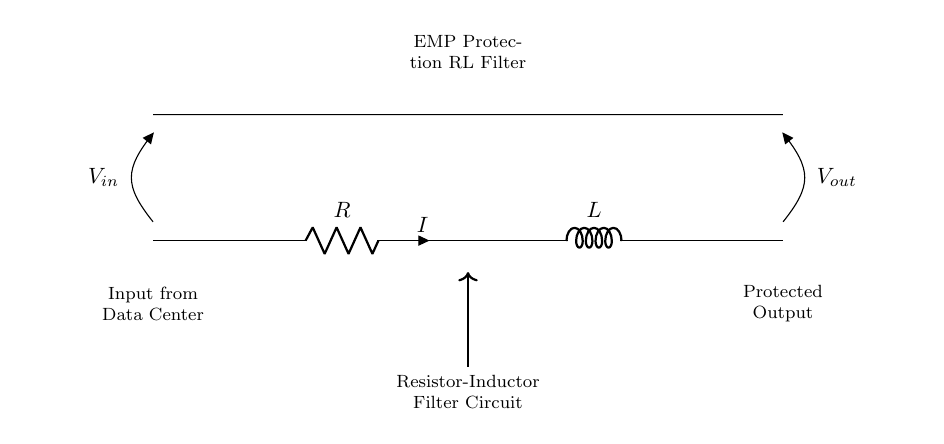What is the component labeled "R"? The component labeled "R" is a resistor, which is used to limit current in the circuit.
Answer: Resistor What is the component labeled "L"? The component labeled "L" is an inductor, which stores energy in the magnetic field and is used to filter frequencies.
Answer: Inductor What is the role of the resistor in this circuit? The resistor limits the current flow, helping to reduce the impact of electromagnetic interference from an EMP event.
Answer: Current limiter What does "V_in" represent? "V_in" represents the input voltage supplied to the circuit from the data center.
Answer: Input voltage What effect would increasing the value of the inductor have on the filter performance? Increasing the inductor's value would improve filter performance by increasing impedance to high-frequency signals, allowing better attenuation of EMP noise.
Answer: Improved attenuation What happens to the output voltage “V_out” when the input voltage “V_in” is increased? As "V_in" is increased, "V_out" will also increase, but the relationship depends on the current and the characteristics of the RL filter.
Answer: Increases How does the RL filter configuration help in EMP protection? The RL configuration provides impedance matching to absorb and dissipate voltage spikes caused by an EMP, protecting downstream components.
Answer: Absorbs spikes 